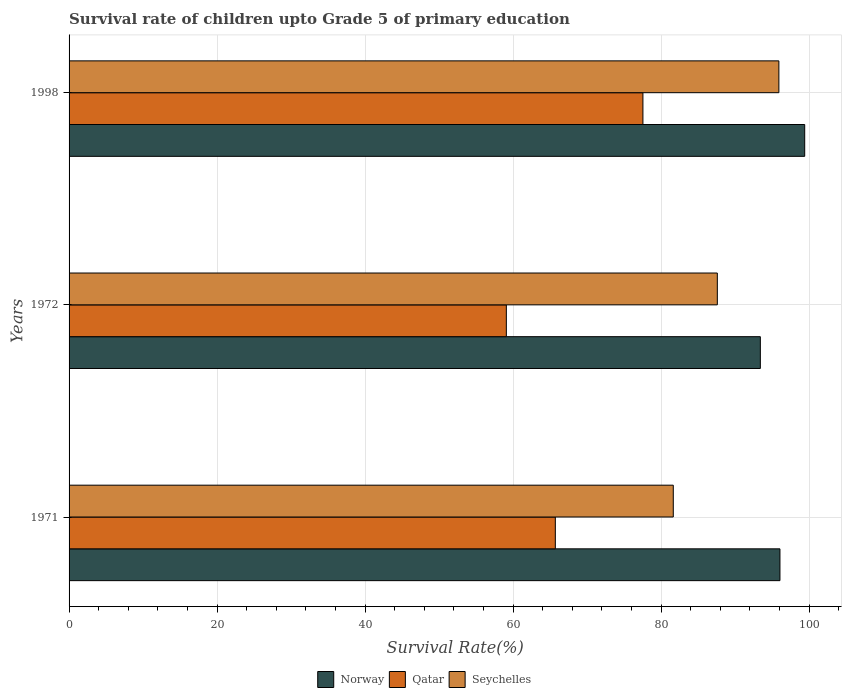Are the number of bars on each tick of the Y-axis equal?
Provide a short and direct response. Yes. How many bars are there on the 2nd tick from the top?
Ensure brevity in your answer.  3. In how many cases, is the number of bars for a given year not equal to the number of legend labels?
Provide a short and direct response. 0. What is the survival rate of children in Norway in 1971?
Ensure brevity in your answer.  96.07. Across all years, what is the maximum survival rate of children in Qatar?
Provide a succinct answer. 77.55. Across all years, what is the minimum survival rate of children in Qatar?
Your response must be concise. 59.09. In which year was the survival rate of children in Qatar minimum?
Keep it short and to the point. 1972. What is the total survival rate of children in Seychelles in the graph?
Your answer should be compact. 265.18. What is the difference between the survival rate of children in Seychelles in 1971 and that in 1972?
Keep it short and to the point. -5.95. What is the difference between the survival rate of children in Seychelles in 1971 and the survival rate of children in Norway in 1972?
Keep it short and to the point. -11.77. What is the average survival rate of children in Qatar per year?
Give a very brief answer. 67.45. In the year 1998, what is the difference between the survival rate of children in Seychelles and survival rate of children in Norway?
Make the answer very short. -3.49. In how many years, is the survival rate of children in Qatar greater than 80 %?
Give a very brief answer. 0. What is the ratio of the survival rate of children in Seychelles in 1972 to that in 1998?
Your response must be concise. 0.91. Is the survival rate of children in Qatar in 1972 less than that in 1998?
Ensure brevity in your answer.  Yes. Is the difference between the survival rate of children in Seychelles in 1971 and 1998 greater than the difference between the survival rate of children in Norway in 1971 and 1998?
Offer a terse response. No. What is the difference between the highest and the second highest survival rate of children in Seychelles?
Provide a succinct answer. 8.32. What is the difference between the highest and the lowest survival rate of children in Qatar?
Your answer should be very brief. 18.46. In how many years, is the survival rate of children in Seychelles greater than the average survival rate of children in Seychelles taken over all years?
Ensure brevity in your answer.  1. What does the 1st bar from the top in 1998 represents?
Provide a short and direct response. Seychelles. What does the 2nd bar from the bottom in 1998 represents?
Give a very brief answer. Qatar. Is it the case that in every year, the sum of the survival rate of children in Qatar and survival rate of children in Norway is greater than the survival rate of children in Seychelles?
Make the answer very short. Yes. What is the difference between two consecutive major ticks on the X-axis?
Offer a very short reply. 20. Are the values on the major ticks of X-axis written in scientific E-notation?
Ensure brevity in your answer.  No. Does the graph contain any zero values?
Offer a very short reply. No. Does the graph contain grids?
Offer a very short reply. Yes. How many legend labels are there?
Provide a short and direct response. 3. What is the title of the graph?
Offer a very short reply. Survival rate of children upto Grade 5 of primary education. What is the label or title of the X-axis?
Offer a terse response. Survival Rate(%). What is the label or title of the Y-axis?
Your answer should be compact. Years. What is the Survival Rate(%) in Norway in 1971?
Offer a terse response. 96.07. What is the Survival Rate(%) of Qatar in 1971?
Your response must be concise. 65.71. What is the Survival Rate(%) of Seychelles in 1971?
Offer a very short reply. 81.65. What is the Survival Rate(%) in Norway in 1972?
Provide a short and direct response. 93.42. What is the Survival Rate(%) in Qatar in 1972?
Provide a short and direct response. 59.09. What is the Survival Rate(%) in Seychelles in 1972?
Provide a short and direct response. 87.61. What is the Survival Rate(%) in Norway in 1998?
Provide a succinct answer. 99.42. What is the Survival Rate(%) of Qatar in 1998?
Provide a succinct answer. 77.55. What is the Survival Rate(%) of Seychelles in 1998?
Provide a short and direct response. 95.92. Across all years, what is the maximum Survival Rate(%) of Norway?
Offer a very short reply. 99.42. Across all years, what is the maximum Survival Rate(%) of Qatar?
Your answer should be very brief. 77.55. Across all years, what is the maximum Survival Rate(%) of Seychelles?
Offer a terse response. 95.92. Across all years, what is the minimum Survival Rate(%) of Norway?
Your answer should be very brief. 93.42. Across all years, what is the minimum Survival Rate(%) of Qatar?
Your answer should be very brief. 59.09. Across all years, what is the minimum Survival Rate(%) of Seychelles?
Keep it short and to the point. 81.65. What is the total Survival Rate(%) of Norway in the graph?
Your answer should be very brief. 288.91. What is the total Survival Rate(%) in Qatar in the graph?
Ensure brevity in your answer.  202.36. What is the total Survival Rate(%) of Seychelles in the graph?
Your answer should be very brief. 265.18. What is the difference between the Survival Rate(%) of Norway in 1971 and that in 1972?
Ensure brevity in your answer.  2.65. What is the difference between the Survival Rate(%) of Qatar in 1971 and that in 1972?
Your answer should be compact. 6.62. What is the difference between the Survival Rate(%) of Seychelles in 1971 and that in 1972?
Make the answer very short. -5.95. What is the difference between the Survival Rate(%) in Norway in 1971 and that in 1998?
Provide a short and direct response. -3.35. What is the difference between the Survival Rate(%) of Qatar in 1971 and that in 1998?
Your answer should be compact. -11.84. What is the difference between the Survival Rate(%) in Seychelles in 1971 and that in 1998?
Provide a succinct answer. -14.27. What is the difference between the Survival Rate(%) of Norway in 1972 and that in 1998?
Keep it short and to the point. -6. What is the difference between the Survival Rate(%) of Qatar in 1972 and that in 1998?
Provide a succinct answer. -18.46. What is the difference between the Survival Rate(%) in Seychelles in 1972 and that in 1998?
Offer a terse response. -8.32. What is the difference between the Survival Rate(%) of Norway in 1971 and the Survival Rate(%) of Qatar in 1972?
Ensure brevity in your answer.  36.98. What is the difference between the Survival Rate(%) in Norway in 1971 and the Survival Rate(%) in Seychelles in 1972?
Make the answer very short. 8.46. What is the difference between the Survival Rate(%) of Qatar in 1971 and the Survival Rate(%) of Seychelles in 1972?
Your answer should be very brief. -21.89. What is the difference between the Survival Rate(%) of Norway in 1971 and the Survival Rate(%) of Qatar in 1998?
Your answer should be very brief. 18.52. What is the difference between the Survival Rate(%) in Norway in 1971 and the Survival Rate(%) in Seychelles in 1998?
Keep it short and to the point. 0.15. What is the difference between the Survival Rate(%) in Qatar in 1971 and the Survival Rate(%) in Seychelles in 1998?
Provide a succinct answer. -30.21. What is the difference between the Survival Rate(%) of Norway in 1972 and the Survival Rate(%) of Qatar in 1998?
Offer a very short reply. 15.87. What is the difference between the Survival Rate(%) in Norway in 1972 and the Survival Rate(%) in Seychelles in 1998?
Provide a short and direct response. -2.5. What is the difference between the Survival Rate(%) in Qatar in 1972 and the Survival Rate(%) in Seychelles in 1998?
Offer a very short reply. -36.83. What is the average Survival Rate(%) of Norway per year?
Provide a short and direct response. 96.3. What is the average Survival Rate(%) in Qatar per year?
Give a very brief answer. 67.45. What is the average Survival Rate(%) of Seychelles per year?
Make the answer very short. 88.39. In the year 1971, what is the difference between the Survival Rate(%) in Norway and Survival Rate(%) in Qatar?
Provide a succinct answer. 30.36. In the year 1971, what is the difference between the Survival Rate(%) of Norway and Survival Rate(%) of Seychelles?
Keep it short and to the point. 14.42. In the year 1971, what is the difference between the Survival Rate(%) of Qatar and Survival Rate(%) of Seychelles?
Ensure brevity in your answer.  -15.94. In the year 1972, what is the difference between the Survival Rate(%) in Norway and Survival Rate(%) in Qatar?
Provide a short and direct response. 34.33. In the year 1972, what is the difference between the Survival Rate(%) in Norway and Survival Rate(%) in Seychelles?
Make the answer very short. 5.81. In the year 1972, what is the difference between the Survival Rate(%) in Qatar and Survival Rate(%) in Seychelles?
Provide a succinct answer. -28.51. In the year 1998, what is the difference between the Survival Rate(%) in Norway and Survival Rate(%) in Qatar?
Offer a very short reply. 21.86. In the year 1998, what is the difference between the Survival Rate(%) of Norway and Survival Rate(%) of Seychelles?
Keep it short and to the point. 3.49. In the year 1998, what is the difference between the Survival Rate(%) in Qatar and Survival Rate(%) in Seychelles?
Ensure brevity in your answer.  -18.37. What is the ratio of the Survival Rate(%) of Norway in 1971 to that in 1972?
Ensure brevity in your answer.  1.03. What is the ratio of the Survival Rate(%) of Qatar in 1971 to that in 1972?
Give a very brief answer. 1.11. What is the ratio of the Survival Rate(%) of Seychelles in 1971 to that in 1972?
Provide a short and direct response. 0.93. What is the ratio of the Survival Rate(%) of Norway in 1971 to that in 1998?
Offer a very short reply. 0.97. What is the ratio of the Survival Rate(%) of Qatar in 1971 to that in 1998?
Ensure brevity in your answer.  0.85. What is the ratio of the Survival Rate(%) of Seychelles in 1971 to that in 1998?
Your answer should be very brief. 0.85. What is the ratio of the Survival Rate(%) in Norway in 1972 to that in 1998?
Ensure brevity in your answer.  0.94. What is the ratio of the Survival Rate(%) of Qatar in 1972 to that in 1998?
Your answer should be very brief. 0.76. What is the ratio of the Survival Rate(%) of Seychelles in 1972 to that in 1998?
Give a very brief answer. 0.91. What is the difference between the highest and the second highest Survival Rate(%) in Norway?
Offer a terse response. 3.35. What is the difference between the highest and the second highest Survival Rate(%) of Qatar?
Give a very brief answer. 11.84. What is the difference between the highest and the second highest Survival Rate(%) in Seychelles?
Offer a terse response. 8.32. What is the difference between the highest and the lowest Survival Rate(%) of Norway?
Ensure brevity in your answer.  6. What is the difference between the highest and the lowest Survival Rate(%) in Qatar?
Offer a very short reply. 18.46. What is the difference between the highest and the lowest Survival Rate(%) of Seychelles?
Give a very brief answer. 14.27. 